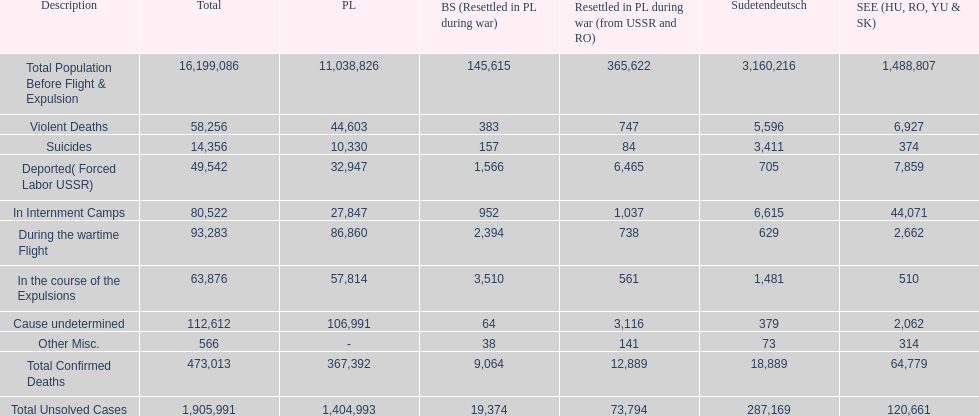What was the cause of the most deaths? Cause undetermined. 